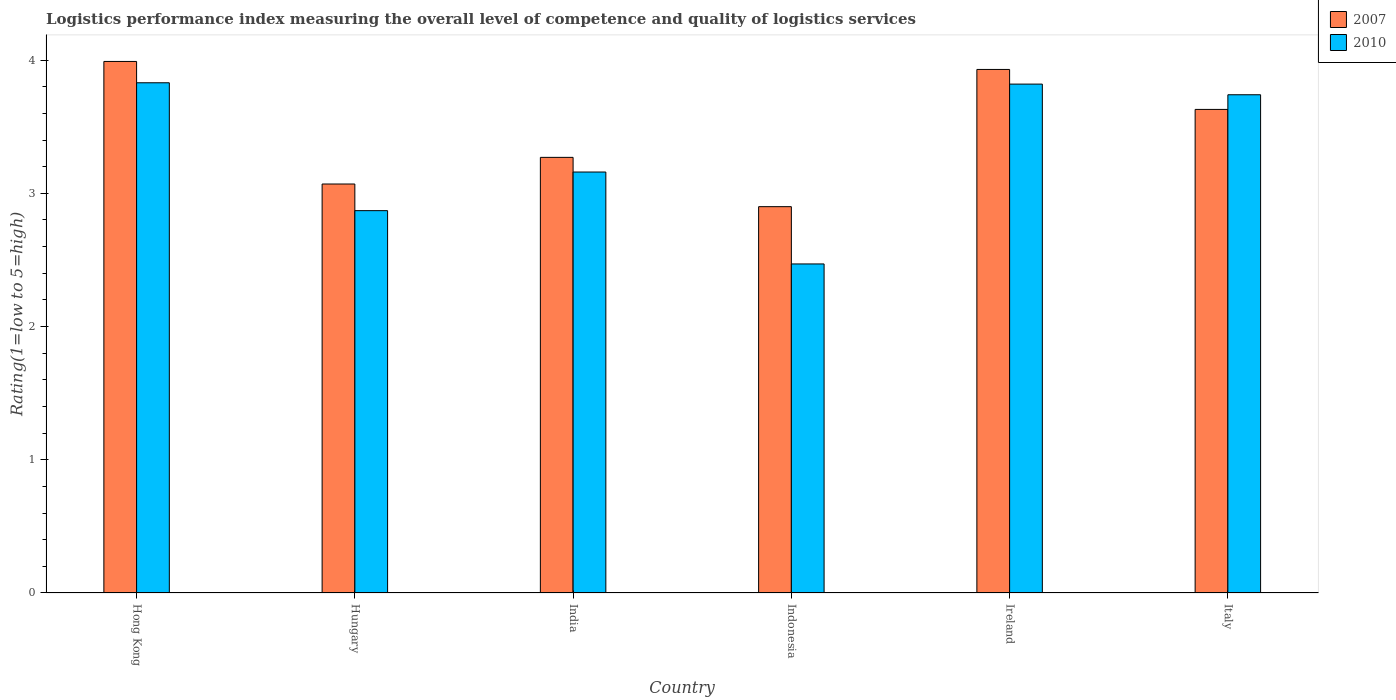How many groups of bars are there?
Provide a succinct answer. 6. How many bars are there on the 1st tick from the left?
Offer a very short reply. 2. In how many cases, is the number of bars for a given country not equal to the number of legend labels?
Provide a short and direct response. 0. What is the Logistic performance index in 2007 in Hungary?
Provide a succinct answer. 3.07. Across all countries, what is the maximum Logistic performance index in 2010?
Give a very brief answer. 3.83. Across all countries, what is the minimum Logistic performance index in 2010?
Provide a succinct answer. 2.47. In which country was the Logistic performance index in 2007 maximum?
Make the answer very short. Hong Kong. What is the total Logistic performance index in 2010 in the graph?
Ensure brevity in your answer.  19.89. What is the difference between the Logistic performance index in 2010 in Hong Kong and that in Indonesia?
Offer a terse response. 1.36. What is the difference between the Logistic performance index in 2010 in Ireland and the Logistic performance index in 2007 in Hong Kong?
Provide a short and direct response. -0.17. What is the average Logistic performance index in 2010 per country?
Your answer should be compact. 3.31. What is the difference between the Logistic performance index of/in 2007 and Logistic performance index of/in 2010 in Indonesia?
Your answer should be compact. 0.43. What is the ratio of the Logistic performance index in 2007 in Indonesia to that in Ireland?
Your answer should be very brief. 0.74. What is the difference between the highest and the second highest Logistic performance index in 2007?
Ensure brevity in your answer.  -0.06. What is the difference between the highest and the lowest Logistic performance index in 2010?
Ensure brevity in your answer.  1.36. Is the sum of the Logistic performance index in 2010 in India and Italy greater than the maximum Logistic performance index in 2007 across all countries?
Offer a terse response. Yes. What does the 1st bar from the left in Hong Kong represents?
Provide a short and direct response. 2007. What does the 2nd bar from the right in India represents?
Give a very brief answer. 2007. Are all the bars in the graph horizontal?
Provide a succinct answer. No. What is the difference between two consecutive major ticks on the Y-axis?
Offer a very short reply. 1. Are the values on the major ticks of Y-axis written in scientific E-notation?
Your response must be concise. No. Does the graph contain any zero values?
Your response must be concise. No. Does the graph contain grids?
Give a very brief answer. No. Where does the legend appear in the graph?
Provide a succinct answer. Top right. How many legend labels are there?
Offer a terse response. 2. What is the title of the graph?
Your answer should be compact. Logistics performance index measuring the overall level of competence and quality of logistics services. Does "1992" appear as one of the legend labels in the graph?
Offer a very short reply. No. What is the label or title of the Y-axis?
Provide a succinct answer. Rating(1=low to 5=high). What is the Rating(1=low to 5=high) of 2007 in Hong Kong?
Your response must be concise. 3.99. What is the Rating(1=low to 5=high) of 2010 in Hong Kong?
Keep it short and to the point. 3.83. What is the Rating(1=low to 5=high) in 2007 in Hungary?
Ensure brevity in your answer.  3.07. What is the Rating(1=low to 5=high) of 2010 in Hungary?
Your answer should be very brief. 2.87. What is the Rating(1=low to 5=high) of 2007 in India?
Your response must be concise. 3.27. What is the Rating(1=low to 5=high) in 2010 in India?
Offer a terse response. 3.16. What is the Rating(1=low to 5=high) of 2007 in Indonesia?
Provide a short and direct response. 2.9. What is the Rating(1=low to 5=high) in 2010 in Indonesia?
Provide a short and direct response. 2.47. What is the Rating(1=low to 5=high) of 2007 in Ireland?
Your answer should be compact. 3.93. What is the Rating(1=low to 5=high) of 2010 in Ireland?
Your answer should be compact. 3.82. What is the Rating(1=low to 5=high) of 2007 in Italy?
Offer a terse response. 3.63. What is the Rating(1=low to 5=high) of 2010 in Italy?
Offer a very short reply. 3.74. Across all countries, what is the maximum Rating(1=low to 5=high) in 2007?
Keep it short and to the point. 3.99. Across all countries, what is the maximum Rating(1=low to 5=high) of 2010?
Make the answer very short. 3.83. Across all countries, what is the minimum Rating(1=low to 5=high) of 2007?
Offer a terse response. 2.9. Across all countries, what is the minimum Rating(1=low to 5=high) in 2010?
Make the answer very short. 2.47. What is the total Rating(1=low to 5=high) in 2007 in the graph?
Give a very brief answer. 20.79. What is the total Rating(1=low to 5=high) of 2010 in the graph?
Give a very brief answer. 19.89. What is the difference between the Rating(1=low to 5=high) of 2007 in Hong Kong and that in India?
Your response must be concise. 0.72. What is the difference between the Rating(1=low to 5=high) of 2010 in Hong Kong and that in India?
Your answer should be compact. 0.67. What is the difference between the Rating(1=low to 5=high) in 2007 in Hong Kong and that in Indonesia?
Your answer should be compact. 1.09. What is the difference between the Rating(1=low to 5=high) in 2010 in Hong Kong and that in Indonesia?
Provide a short and direct response. 1.36. What is the difference between the Rating(1=low to 5=high) in 2007 in Hong Kong and that in Ireland?
Offer a terse response. 0.06. What is the difference between the Rating(1=low to 5=high) of 2007 in Hong Kong and that in Italy?
Your answer should be compact. 0.36. What is the difference between the Rating(1=low to 5=high) of 2010 in Hong Kong and that in Italy?
Your answer should be compact. 0.09. What is the difference between the Rating(1=low to 5=high) in 2010 in Hungary and that in India?
Your answer should be compact. -0.29. What is the difference between the Rating(1=low to 5=high) of 2007 in Hungary and that in Indonesia?
Offer a very short reply. 0.17. What is the difference between the Rating(1=low to 5=high) in 2007 in Hungary and that in Ireland?
Give a very brief answer. -0.86. What is the difference between the Rating(1=low to 5=high) in 2010 in Hungary and that in Ireland?
Your response must be concise. -0.95. What is the difference between the Rating(1=low to 5=high) in 2007 in Hungary and that in Italy?
Ensure brevity in your answer.  -0.56. What is the difference between the Rating(1=low to 5=high) in 2010 in Hungary and that in Italy?
Offer a very short reply. -0.87. What is the difference between the Rating(1=low to 5=high) of 2007 in India and that in Indonesia?
Your answer should be compact. 0.37. What is the difference between the Rating(1=low to 5=high) in 2010 in India and that in Indonesia?
Your response must be concise. 0.69. What is the difference between the Rating(1=low to 5=high) of 2007 in India and that in Ireland?
Offer a very short reply. -0.66. What is the difference between the Rating(1=low to 5=high) of 2010 in India and that in Ireland?
Your response must be concise. -0.66. What is the difference between the Rating(1=low to 5=high) of 2007 in India and that in Italy?
Give a very brief answer. -0.36. What is the difference between the Rating(1=low to 5=high) of 2010 in India and that in Italy?
Give a very brief answer. -0.58. What is the difference between the Rating(1=low to 5=high) in 2007 in Indonesia and that in Ireland?
Your answer should be compact. -1.03. What is the difference between the Rating(1=low to 5=high) in 2010 in Indonesia and that in Ireland?
Offer a very short reply. -1.35. What is the difference between the Rating(1=low to 5=high) in 2007 in Indonesia and that in Italy?
Offer a very short reply. -0.73. What is the difference between the Rating(1=low to 5=high) in 2010 in Indonesia and that in Italy?
Your answer should be very brief. -1.27. What is the difference between the Rating(1=low to 5=high) in 2007 in Hong Kong and the Rating(1=low to 5=high) in 2010 in Hungary?
Make the answer very short. 1.12. What is the difference between the Rating(1=low to 5=high) in 2007 in Hong Kong and the Rating(1=low to 5=high) in 2010 in India?
Give a very brief answer. 0.83. What is the difference between the Rating(1=low to 5=high) in 2007 in Hong Kong and the Rating(1=low to 5=high) in 2010 in Indonesia?
Give a very brief answer. 1.52. What is the difference between the Rating(1=low to 5=high) in 2007 in Hong Kong and the Rating(1=low to 5=high) in 2010 in Ireland?
Provide a succinct answer. 0.17. What is the difference between the Rating(1=low to 5=high) of 2007 in Hungary and the Rating(1=low to 5=high) of 2010 in India?
Give a very brief answer. -0.09. What is the difference between the Rating(1=low to 5=high) in 2007 in Hungary and the Rating(1=low to 5=high) in 2010 in Indonesia?
Provide a succinct answer. 0.6. What is the difference between the Rating(1=low to 5=high) in 2007 in Hungary and the Rating(1=low to 5=high) in 2010 in Ireland?
Provide a succinct answer. -0.75. What is the difference between the Rating(1=low to 5=high) in 2007 in Hungary and the Rating(1=low to 5=high) in 2010 in Italy?
Provide a short and direct response. -0.67. What is the difference between the Rating(1=low to 5=high) in 2007 in India and the Rating(1=low to 5=high) in 2010 in Indonesia?
Give a very brief answer. 0.8. What is the difference between the Rating(1=low to 5=high) of 2007 in India and the Rating(1=low to 5=high) of 2010 in Ireland?
Your answer should be compact. -0.55. What is the difference between the Rating(1=low to 5=high) in 2007 in India and the Rating(1=low to 5=high) in 2010 in Italy?
Give a very brief answer. -0.47. What is the difference between the Rating(1=low to 5=high) of 2007 in Indonesia and the Rating(1=low to 5=high) of 2010 in Ireland?
Provide a succinct answer. -0.92. What is the difference between the Rating(1=low to 5=high) of 2007 in Indonesia and the Rating(1=low to 5=high) of 2010 in Italy?
Provide a short and direct response. -0.84. What is the difference between the Rating(1=low to 5=high) of 2007 in Ireland and the Rating(1=low to 5=high) of 2010 in Italy?
Provide a succinct answer. 0.19. What is the average Rating(1=low to 5=high) in 2007 per country?
Offer a terse response. 3.46. What is the average Rating(1=low to 5=high) in 2010 per country?
Offer a very short reply. 3.31. What is the difference between the Rating(1=low to 5=high) in 2007 and Rating(1=low to 5=high) in 2010 in Hong Kong?
Keep it short and to the point. 0.16. What is the difference between the Rating(1=low to 5=high) of 2007 and Rating(1=low to 5=high) of 2010 in Hungary?
Offer a terse response. 0.2. What is the difference between the Rating(1=low to 5=high) in 2007 and Rating(1=low to 5=high) in 2010 in India?
Ensure brevity in your answer.  0.11. What is the difference between the Rating(1=low to 5=high) in 2007 and Rating(1=low to 5=high) in 2010 in Indonesia?
Offer a terse response. 0.43. What is the difference between the Rating(1=low to 5=high) in 2007 and Rating(1=low to 5=high) in 2010 in Ireland?
Offer a very short reply. 0.11. What is the difference between the Rating(1=low to 5=high) in 2007 and Rating(1=low to 5=high) in 2010 in Italy?
Provide a succinct answer. -0.11. What is the ratio of the Rating(1=low to 5=high) of 2007 in Hong Kong to that in Hungary?
Your response must be concise. 1.3. What is the ratio of the Rating(1=low to 5=high) in 2010 in Hong Kong to that in Hungary?
Give a very brief answer. 1.33. What is the ratio of the Rating(1=low to 5=high) of 2007 in Hong Kong to that in India?
Ensure brevity in your answer.  1.22. What is the ratio of the Rating(1=low to 5=high) in 2010 in Hong Kong to that in India?
Provide a succinct answer. 1.21. What is the ratio of the Rating(1=low to 5=high) of 2007 in Hong Kong to that in Indonesia?
Give a very brief answer. 1.38. What is the ratio of the Rating(1=low to 5=high) of 2010 in Hong Kong to that in Indonesia?
Your answer should be compact. 1.55. What is the ratio of the Rating(1=low to 5=high) of 2007 in Hong Kong to that in Ireland?
Your answer should be very brief. 1.02. What is the ratio of the Rating(1=low to 5=high) in 2007 in Hong Kong to that in Italy?
Make the answer very short. 1.1. What is the ratio of the Rating(1=low to 5=high) in 2010 in Hong Kong to that in Italy?
Provide a succinct answer. 1.02. What is the ratio of the Rating(1=low to 5=high) of 2007 in Hungary to that in India?
Give a very brief answer. 0.94. What is the ratio of the Rating(1=low to 5=high) in 2010 in Hungary to that in India?
Your answer should be compact. 0.91. What is the ratio of the Rating(1=low to 5=high) in 2007 in Hungary to that in Indonesia?
Your response must be concise. 1.06. What is the ratio of the Rating(1=low to 5=high) of 2010 in Hungary to that in Indonesia?
Offer a very short reply. 1.16. What is the ratio of the Rating(1=low to 5=high) in 2007 in Hungary to that in Ireland?
Make the answer very short. 0.78. What is the ratio of the Rating(1=low to 5=high) in 2010 in Hungary to that in Ireland?
Offer a terse response. 0.75. What is the ratio of the Rating(1=low to 5=high) of 2007 in Hungary to that in Italy?
Offer a very short reply. 0.85. What is the ratio of the Rating(1=low to 5=high) in 2010 in Hungary to that in Italy?
Give a very brief answer. 0.77. What is the ratio of the Rating(1=low to 5=high) in 2007 in India to that in Indonesia?
Make the answer very short. 1.13. What is the ratio of the Rating(1=low to 5=high) in 2010 in India to that in Indonesia?
Offer a very short reply. 1.28. What is the ratio of the Rating(1=low to 5=high) of 2007 in India to that in Ireland?
Give a very brief answer. 0.83. What is the ratio of the Rating(1=low to 5=high) in 2010 in India to that in Ireland?
Make the answer very short. 0.83. What is the ratio of the Rating(1=low to 5=high) of 2007 in India to that in Italy?
Offer a terse response. 0.9. What is the ratio of the Rating(1=low to 5=high) of 2010 in India to that in Italy?
Offer a very short reply. 0.84. What is the ratio of the Rating(1=low to 5=high) in 2007 in Indonesia to that in Ireland?
Make the answer very short. 0.74. What is the ratio of the Rating(1=low to 5=high) of 2010 in Indonesia to that in Ireland?
Ensure brevity in your answer.  0.65. What is the ratio of the Rating(1=low to 5=high) of 2007 in Indonesia to that in Italy?
Give a very brief answer. 0.8. What is the ratio of the Rating(1=low to 5=high) of 2010 in Indonesia to that in Italy?
Provide a short and direct response. 0.66. What is the ratio of the Rating(1=low to 5=high) in 2007 in Ireland to that in Italy?
Your answer should be compact. 1.08. What is the ratio of the Rating(1=low to 5=high) of 2010 in Ireland to that in Italy?
Make the answer very short. 1.02. What is the difference between the highest and the second highest Rating(1=low to 5=high) of 2010?
Provide a short and direct response. 0.01. What is the difference between the highest and the lowest Rating(1=low to 5=high) of 2007?
Make the answer very short. 1.09. What is the difference between the highest and the lowest Rating(1=low to 5=high) of 2010?
Provide a succinct answer. 1.36. 